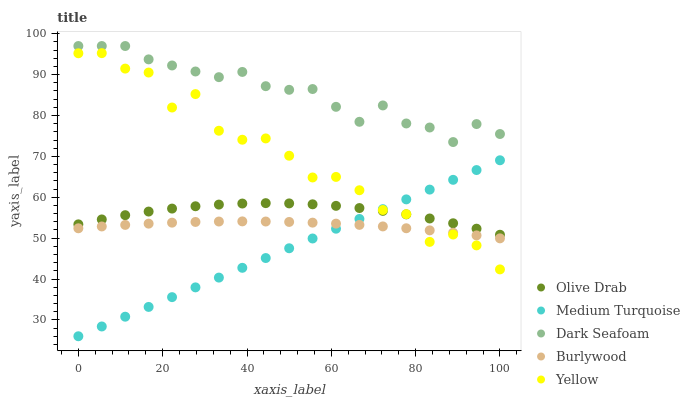Does Medium Turquoise have the minimum area under the curve?
Answer yes or no. Yes. Does Dark Seafoam have the maximum area under the curve?
Answer yes or no. Yes. Does Yellow have the minimum area under the curve?
Answer yes or no. No. Does Yellow have the maximum area under the curve?
Answer yes or no. No. Is Medium Turquoise the smoothest?
Answer yes or no. Yes. Is Yellow the roughest?
Answer yes or no. Yes. Is Dark Seafoam the smoothest?
Answer yes or no. No. Is Dark Seafoam the roughest?
Answer yes or no. No. Does Medium Turquoise have the lowest value?
Answer yes or no. Yes. Does Yellow have the lowest value?
Answer yes or no. No. Does Dark Seafoam have the highest value?
Answer yes or no. Yes. Does Yellow have the highest value?
Answer yes or no. No. Is Burlywood less than Dark Seafoam?
Answer yes or no. Yes. Is Dark Seafoam greater than Burlywood?
Answer yes or no. Yes. Does Burlywood intersect Yellow?
Answer yes or no. Yes. Is Burlywood less than Yellow?
Answer yes or no. No. Is Burlywood greater than Yellow?
Answer yes or no. No. Does Burlywood intersect Dark Seafoam?
Answer yes or no. No. 